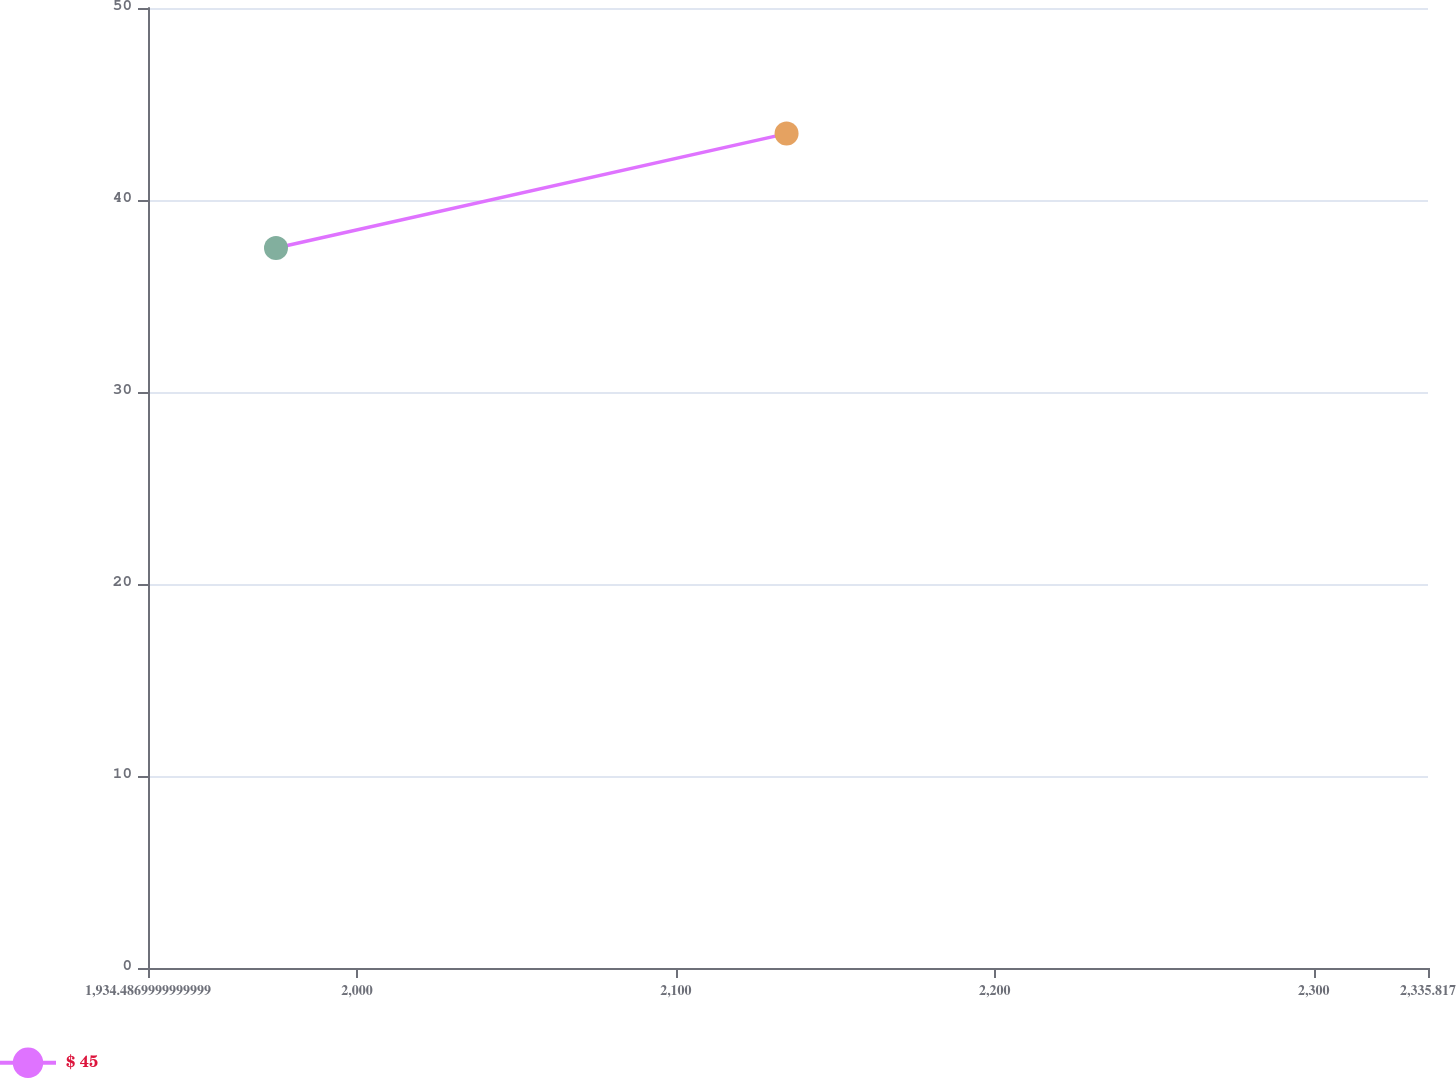Convert chart. <chart><loc_0><loc_0><loc_500><loc_500><line_chart><ecel><fcel>$ 45<nl><fcel>1974.62<fcel>37.5<nl><fcel>2134.7<fcel>43.46<nl><fcel>2338.98<fcel>47.65<nl><fcel>2375.95<fcel>35.52<nl></chart> 